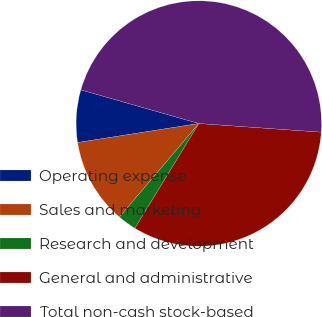Convert chart to OTSL. <chart><loc_0><loc_0><loc_500><loc_500><pie_chart><fcel>Operating expense<fcel>Sales and marketing<fcel>Research and development<fcel>General and administrative<fcel>Total non-cash stock-based<nl><fcel>6.9%<fcel>11.32%<fcel>2.48%<fcel>32.6%<fcel>46.7%<nl></chart> 